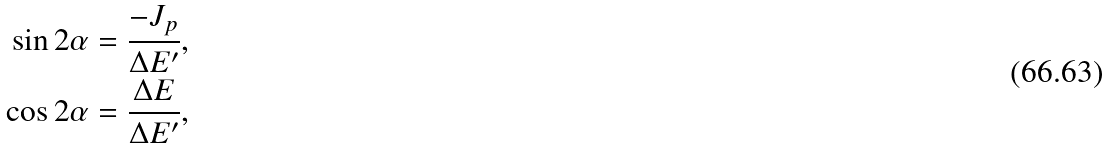Convert formula to latex. <formula><loc_0><loc_0><loc_500><loc_500>\sin 2 \alpha = \frac { - J _ { p } } { \Delta E ^ { \prime } } , \\ \cos 2 \alpha = \frac { \Delta E } { \Delta E ^ { \prime } } ,</formula> 